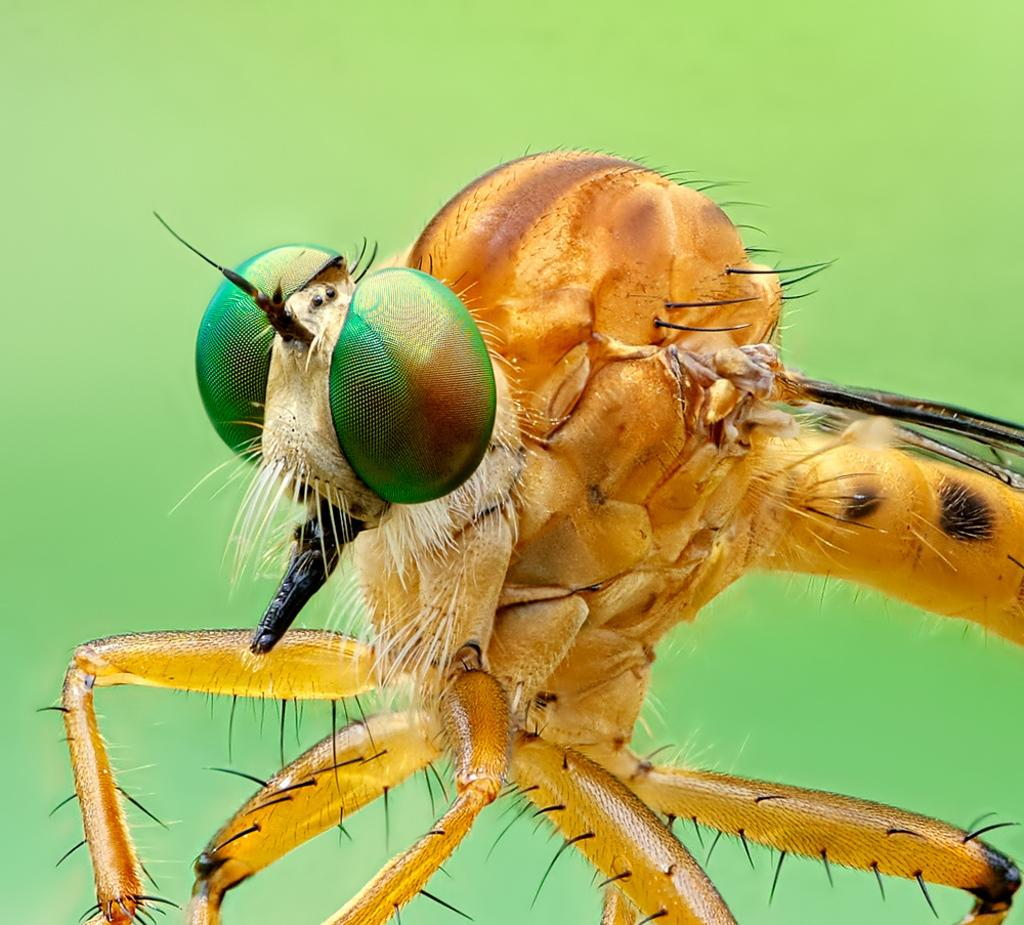What type of creature can be seen in the image? There is an insect in the image. What color is the background of the image? The background of the image is green. What type of pleasure can be seen in the image? There is no pleasure visible in the image; it features an insect and a green background. Can you describe the wilderness in the image? There is no wilderness present in the image; it only contains an insect and a green background. 